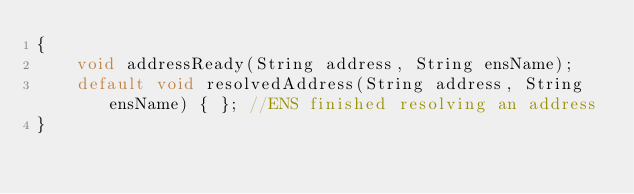<code> <loc_0><loc_0><loc_500><loc_500><_Java_>{
    void addressReady(String address, String ensName);
    default void resolvedAddress(String address, String ensName) { }; //ENS finished resolving an address
}
</code> 